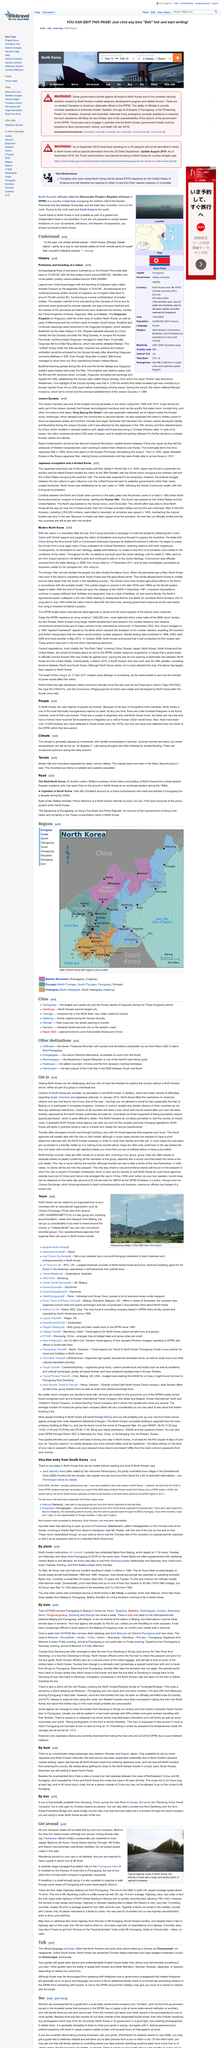Highlight a few significant elements in this photo. Two options are available for individuals interested in visiting North Korea: organizing a tour through a reputable travel agency or volunteering with a respected educational organization. According to Tour, a 5-day group tour that includes accommodation, meals, and transportation from Beijing would cost approximately USD 1000, 900 Euros, and GDP 770... I, as an individual, would travel independently around North Korea, but in the form of a one-person escorted group. 